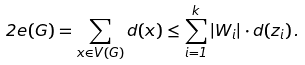Convert formula to latex. <formula><loc_0><loc_0><loc_500><loc_500>2 e ( G ) = \sum _ { x \in V ( G ) } d ( x ) \leq \sum _ { i = 1 } ^ { k } | W _ { i } | \cdot d ( z _ { i } ) \, .</formula> 